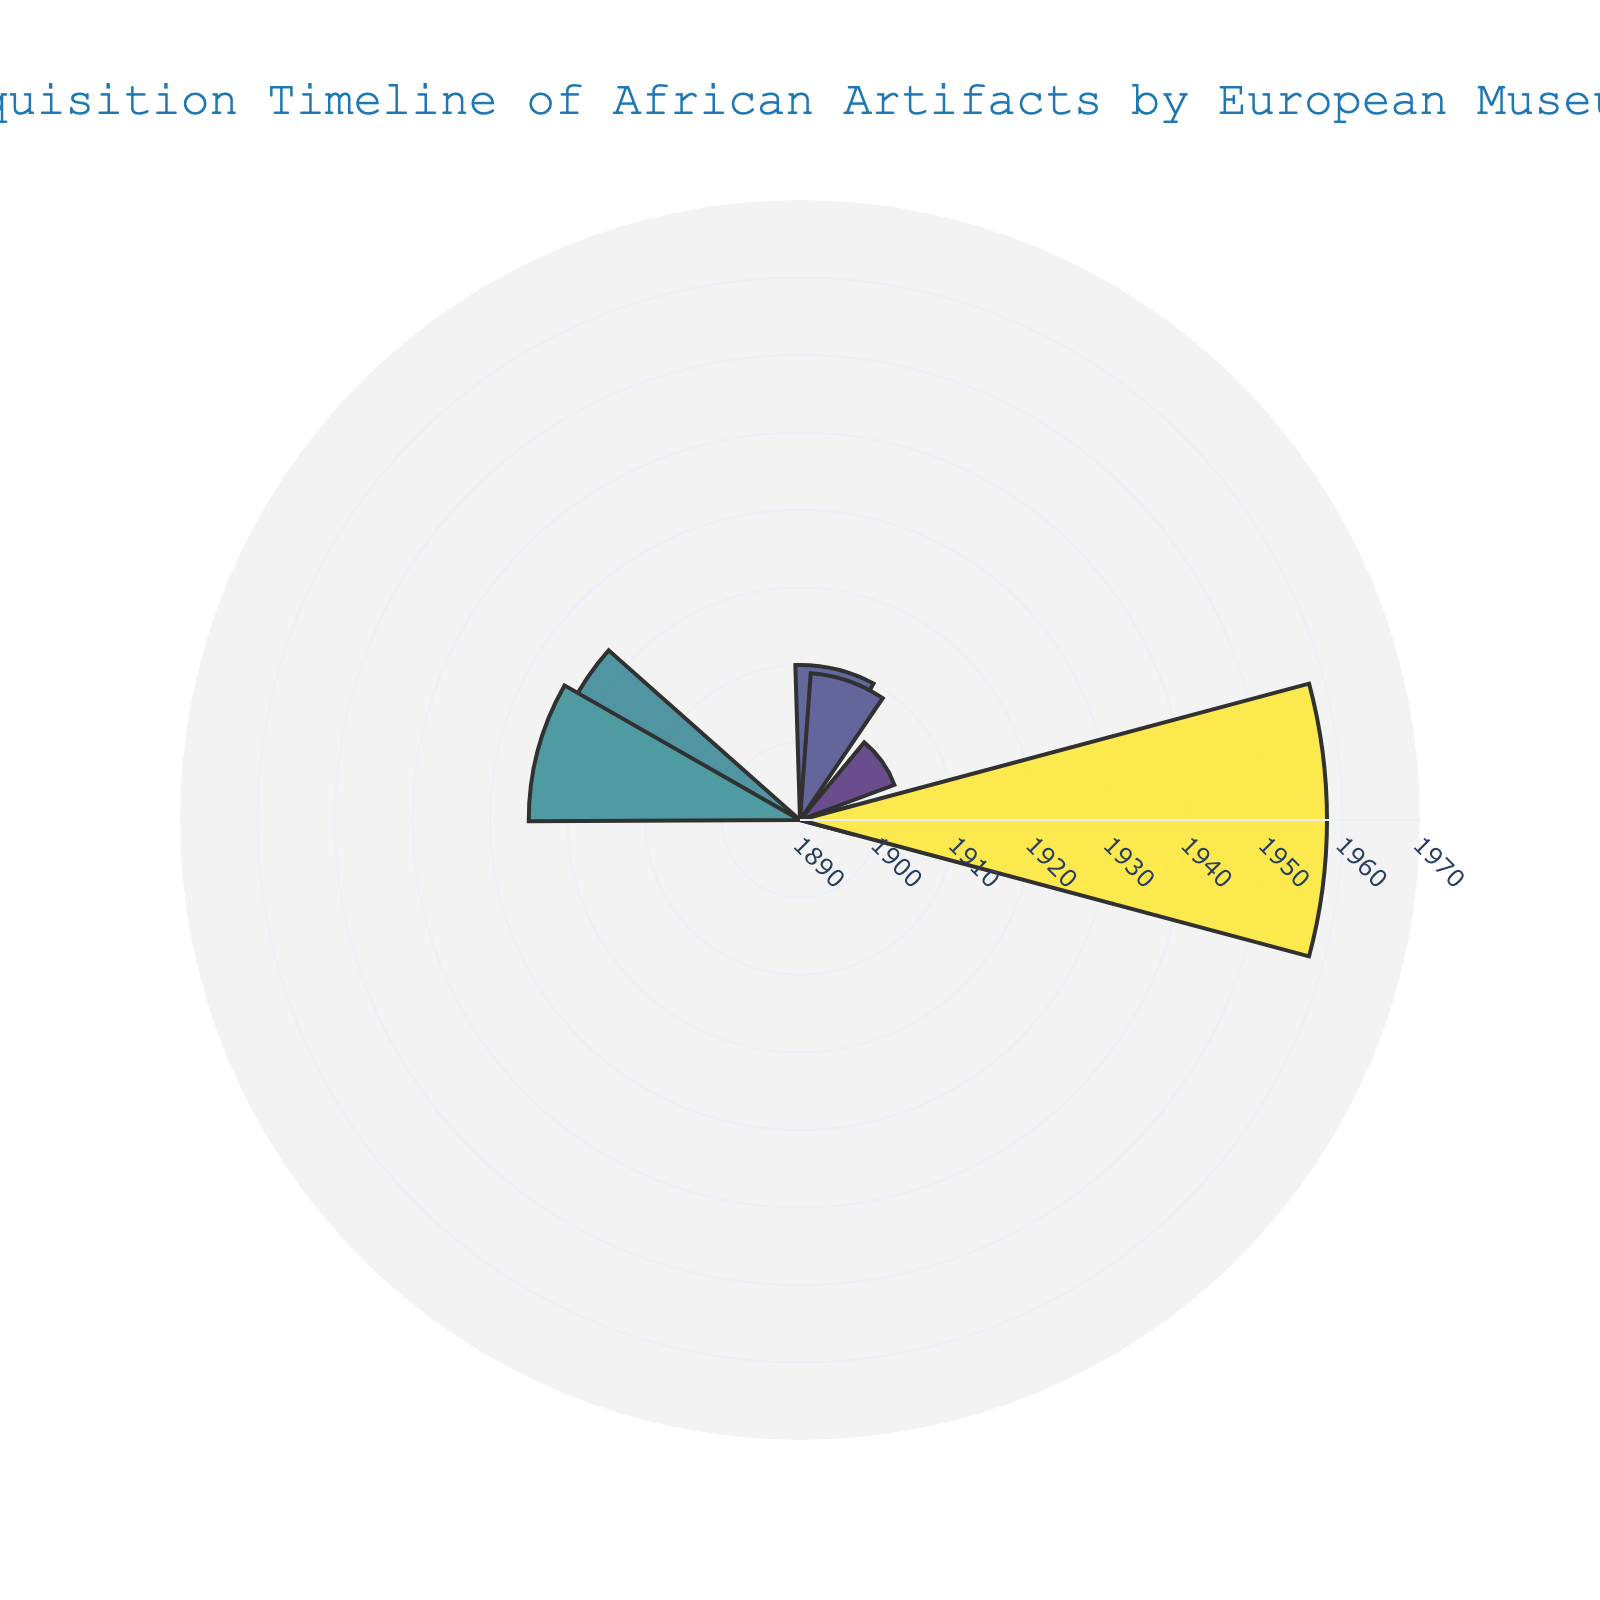What is the title of the figure? The title is prominently displayed at the top of the figure, usually in a larger font size and different color. It summarizes the subject of the figure.
Answer: Acquisition Timeline of African Artifacts by European Museums How many museums are represented in the figure? Count the number of distinct museums listed in the hover text or annotations around the chart.
Answer: 7 Which museum acquired an African artifact earliest? Identify the smallest 'r' value on the plot, as 'r' represents the year of acquisition.
Answer: British Museum What year did the Royal Museum for Central Africa acquire its artifact? Locate the annotation around the chart for the Royal Museum for Central Africa and read off the 'r' value associated with it.
Answer: 1909 How wide are the bars in the chart? The width of the bars is coded as a constant value; in this case, 30 units.
Answer: 30 How many years after the British Museum did the Victoria and Albert Museum acquire its artifact? Calculate the difference between the years the British Museum (1897) and the Victoria and Albert Museum (1923) acquired their artifacts.
Answer: 26 years Which museum's artifact acquisition is closest in time to that of the Berlin Ethnological Museum? Find the years of artifact acquisition, identify Berlin Ethnological Museum's year (1903), and determine the nearest year among the others (1909 for the Royal Museum for Central Africa).
Answer: Royal Museum for Central Africa Which artifact was acquired last, and by which museum? Identify the highest 'r' value in the plot that corresponds to the year of acquisition.
Answer: Dogon Masks by Musée du Quai Branly What is the range of years during which the artifacts were acquired? Calculate the difference between the earliest year (1897) and the latest year (1958).
Answer: 61 years How many artifacts were acquired before 1920? Count the number of 'r' values (years) less than 1920 in the chart.
Answer: 4 